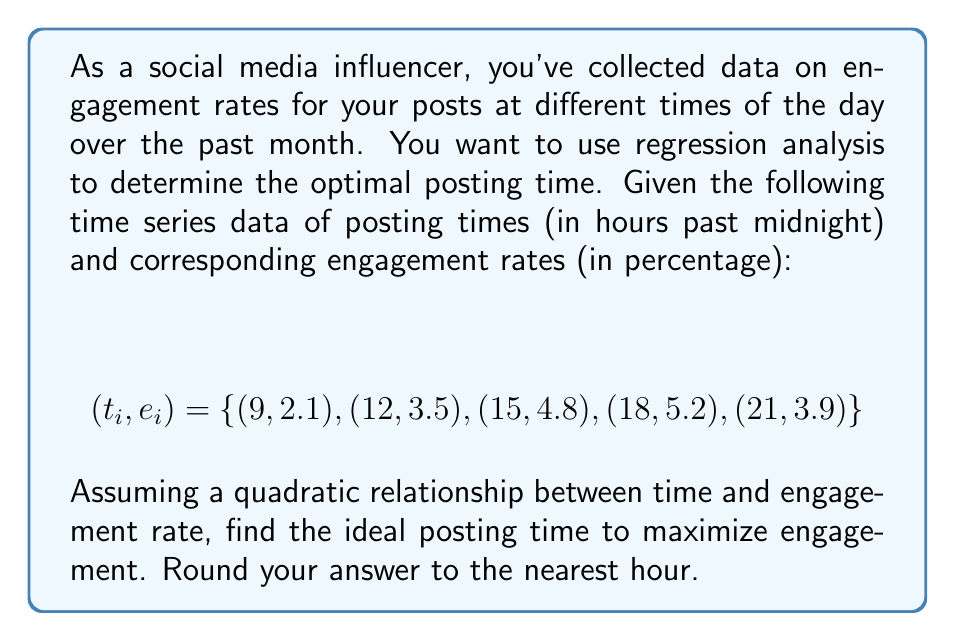What is the answer to this math problem? 1) We assume a quadratic relationship: $e = at^2 + bt + c$

2) To find the coefficients $a$, $b$, and $c$, we need to solve the normal equations:

   $$\begin{bmatrix}
   \sum t_i^4 & \sum t_i^3 & \sum t_i^2 \\
   \sum t_i^3 & \sum t_i^2 & \sum t_i \\
   \sum t_i^2 & \sum t_i & n
   \end{bmatrix}
   \begin{bmatrix}
   a \\ b \\ c
   \end{bmatrix} =
   \begin{bmatrix}
   \sum e_it_i^2 \\ \sum e_it_i \\ \sum e_i
   \end{bmatrix}$$

3) Calculating the sums:
   $\sum t_i^4 = 50,085$
   $\sum t_i^3 = 15,525$
   $\sum t_i^2 = 5,115$
   $\sum t_i = 75$
   $n = 5$
   $\sum e_it_i^2 = 2,646.3$
   $\sum e_it_i = 427.5$
   $\sum e_i = 19.5$

4) Solving the system of equations:
   $$\begin{bmatrix}
   50,085 & 15,525 & 5,115 \\
   15,525 & 5,115 & 75 \\
   5,115 & 75 & 5
   \end{bmatrix}
   \begin{bmatrix}
   a \\ b \\ c
   \end{bmatrix} =
   \begin{bmatrix}
   2,646.3 \\ 427.5 \\ 19.5
   \end{bmatrix}$$

5) The solution gives us:
   $a \approx -0.0325$
   $b \approx 1.0425$
   $c \approx -2.7875$

6) To find the maximum, we differentiate $e$ with respect to $t$ and set it to zero:
   $$\frac{de}{dt} = 2at + b = 0$$
   $$2(-0.0325)t + 1.0425 = 0$$
   $$t = \frac{1.0425}{2(0.0325)} \approx 16.04$$

7) Rounding to the nearest hour gives us 16, which is 4 PM.
Answer: 4 PM 